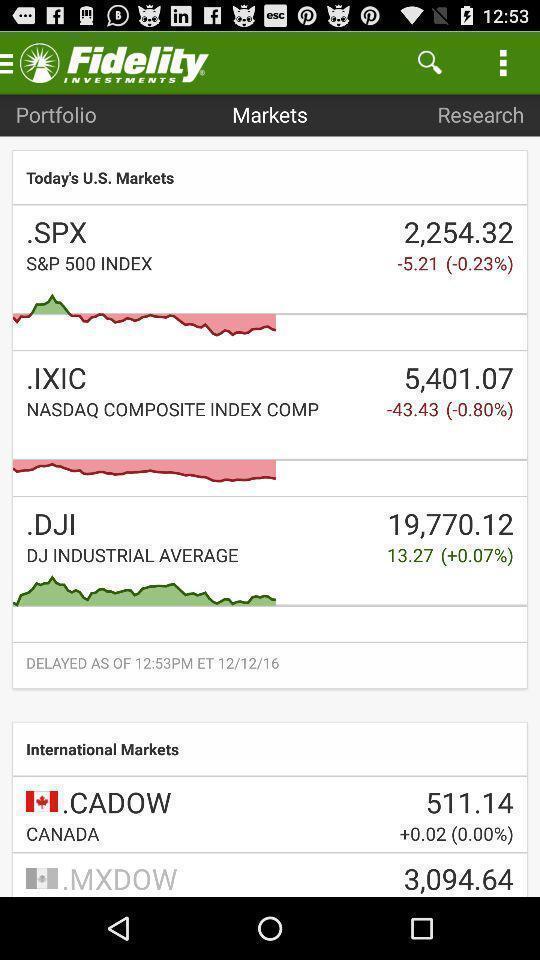What is the overall content of this screenshot? Page displaying the graphs in a financial company app. 